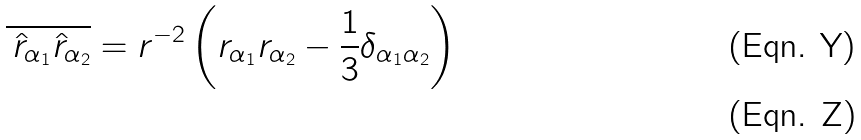Convert formula to latex. <formula><loc_0><loc_0><loc_500><loc_500>\overline { \, \hat { r } _ { \alpha _ { 1 } } \hat { r } _ { \alpha _ { 2 } } } = r ^ { - 2 } \left ( r _ { \alpha _ { 1 } } r _ { \alpha _ { 2 } } - \frac { 1 } { 3 } \delta _ { \alpha _ { 1 } \alpha _ { 2 } } \right ) \\</formula> 